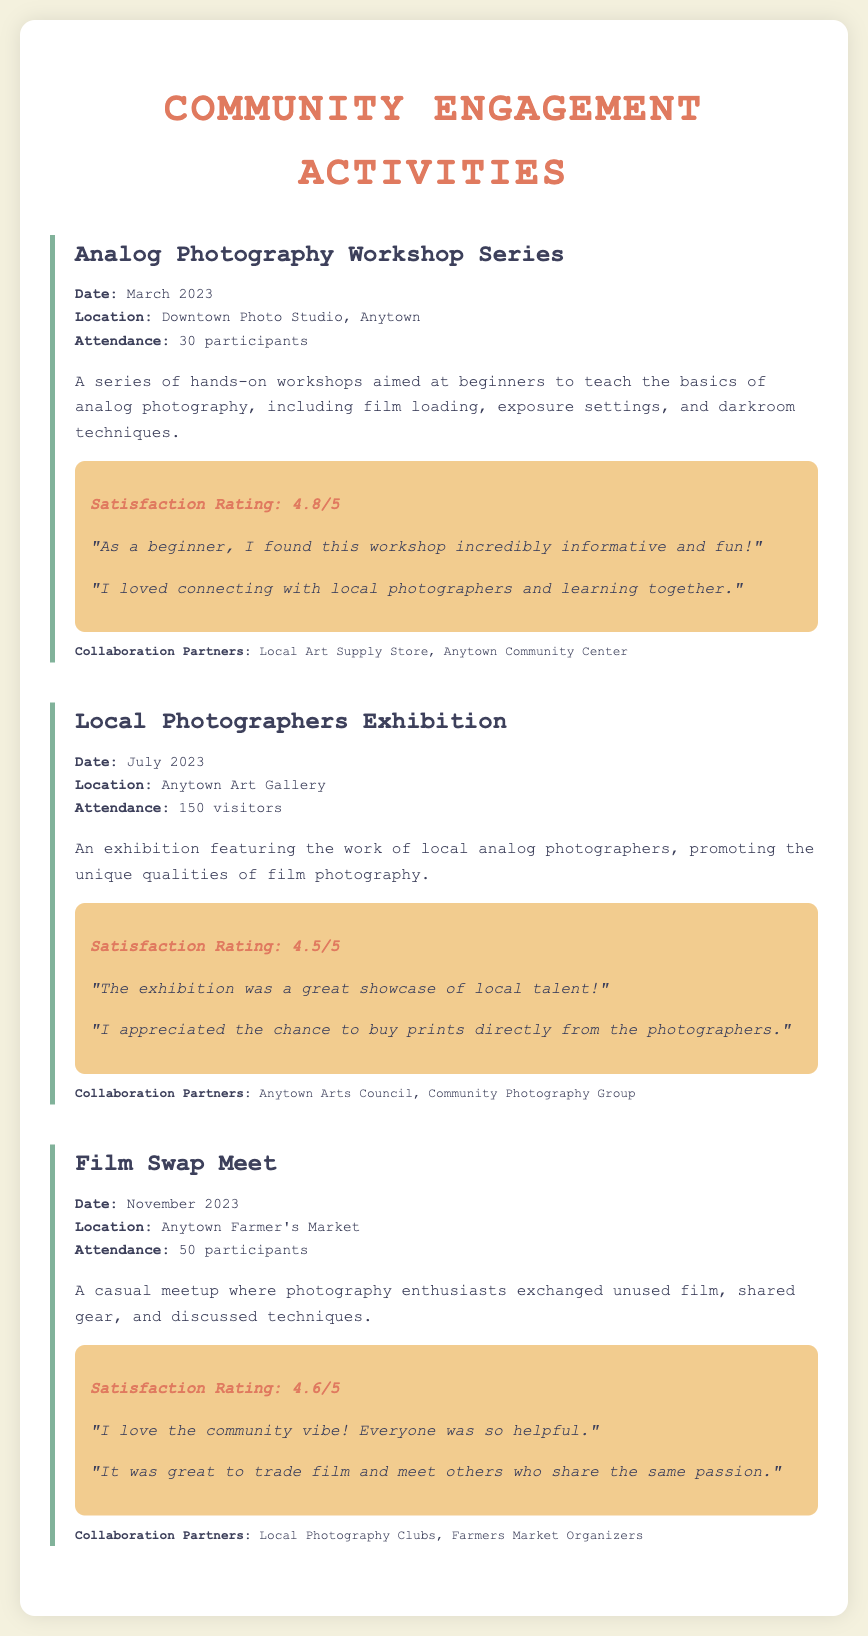what is the date of the Analog Photography Workshop Series? The date is mentioned in the event details, and it is March 2023.
Answer: March 2023 how many participants attended the Local Photographers Exhibition? The attendance figure is provided in the event details, which states 150 visitors.
Answer: 150 visitors what was the satisfaction rating for the Film Swap Meet? The satisfaction rating is included in the feedback section, which shows a rating of 4.6/5.
Answer: 4.6/5 which location hosted the Analog Photography Workshop Series? The location is specified in the event details as Downtown Photo Studio, Anytown.
Answer: Downtown Photo Studio, Anytown what is the main activity of the Film Swap Meet? The main activity is described in the event summary, which states it was a casual meetup for exchanging unused film.
Answer: Exchanging unused film which partners collaborated for the Local Photographers Exhibition? The collaboration partners are listed in the event details, which include Anytown Arts Council and Community Photography Group.
Answer: Anytown Arts Council, Community Photography Group how many workshops were conducted in the Analog Photography Workshop Series? Although the exact number of workshops is not stated, it is referred to as a series, indicating multiple workshops.
Answer: Series (multiple workshops) what is the primary focus of the community engagement activities mentioned? The primary focus, as described throughout the document, is to promote analog photography.
Answer: Promote analog photography 